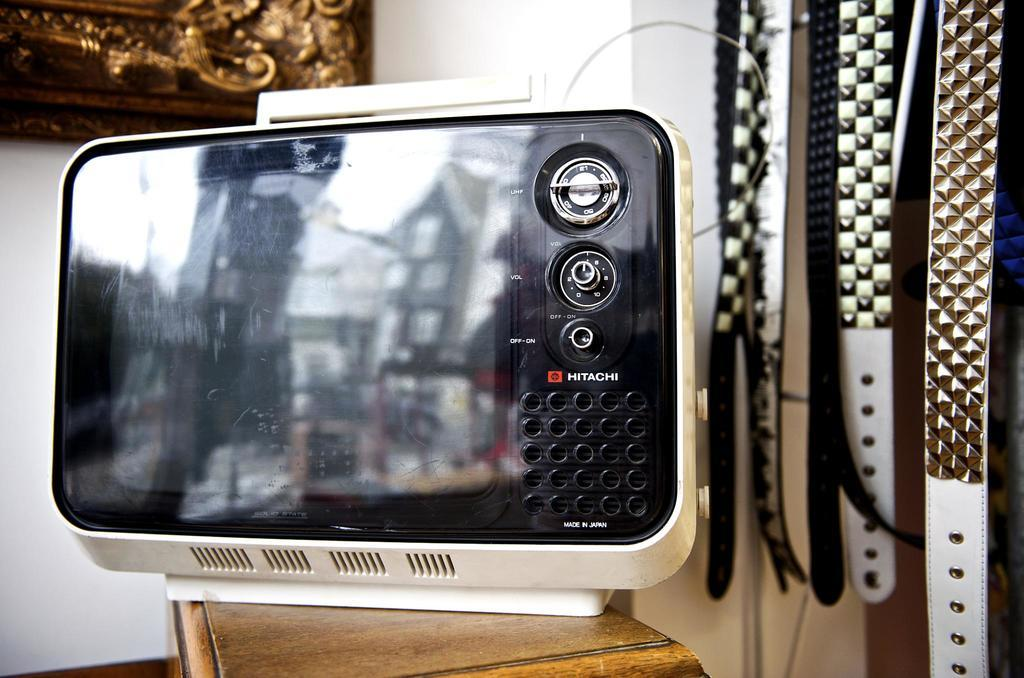<image>
Offer a succinct explanation of the picture presented. A vintage Hitatchi TV with a white shell sitting on a table. 